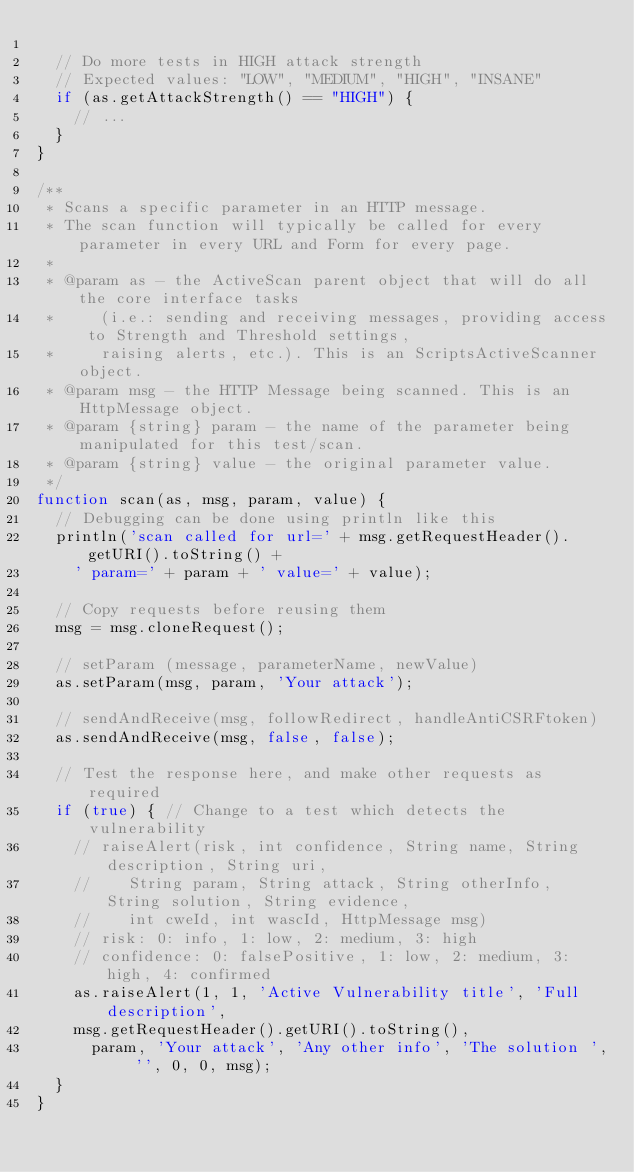<code> <loc_0><loc_0><loc_500><loc_500><_JavaScript_>	
	// Do more tests in HIGH attack strength
	// Expected values: "LOW", "MEDIUM", "HIGH", "INSANE"
	if (as.getAttackStrength() == "HIGH") {
		// ...
	}
}

/**
 * Scans a specific parameter in an HTTP message.
 * The scan function will typically be called for every parameter in every URL and Form for every page.
 * 
 * @param as - the ActiveScan parent object that will do all the core interface tasks 
 *     (i.e.: sending and receiving messages, providing access to Strength and Threshold settings,
 *     raising alerts, etc.). This is an ScriptsActiveScanner object.
 * @param msg - the HTTP Message being scanned. This is an HttpMessage object.
 * @param {string} param - the name of the parameter being manipulated for this test/scan.
 * @param {string} value - the original parameter value.
 */
function scan(as, msg, param, value) {
	// Debugging can be done using println like this
	println('scan called for url=' + msg.getRequestHeader().getURI().toString() + 
		' param=' + param + ' value=' + value);
	
	// Copy requests before reusing them
	msg = msg.cloneRequest();
	
	// setParam (message, parameterName, newValue)
	as.setParam(msg, param, 'Your attack');
	
	// sendAndReceive(msg, followRedirect, handleAntiCSRFtoken)
	as.sendAndReceive(msg, false, false);
	
	// Test the response here, and make other requests as required
	if (true) {	// Change to a test which detects the vulnerability
		// raiseAlert(risk, int confidence, String name, String description, String uri, 
		//		String param, String attack, String otherInfo, String solution, String evidence, 
		//		int cweId, int wascId, HttpMessage msg)
		// risk: 0: info, 1: low, 2: medium, 3: high
		// confidence: 0: falsePositive, 1: low, 2: medium, 3: high, 4: confirmed
		as.raiseAlert(1, 1, 'Active Vulnerability title', 'Full description', 
		msg.getRequestHeader().getURI().toString(), 
			param, 'Your attack', 'Any other info', 'The solution ', '', 0, 0, msg);
	}
}

</code> 